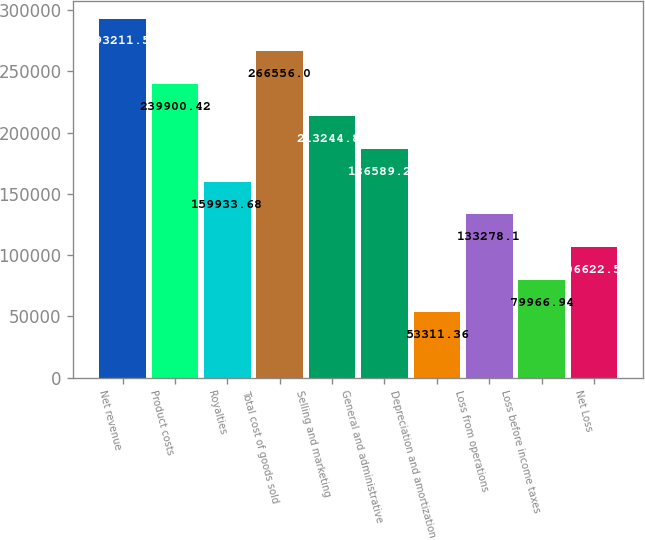Convert chart. <chart><loc_0><loc_0><loc_500><loc_500><bar_chart><fcel>Net revenue<fcel>Product costs<fcel>Royalties<fcel>Total cost of goods sold<fcel>Selling and marketing<fcel>General and administrative<fcel>Depreciation and amortization<fcel>Loss from operations<fcel>Loss before income taxes<fcel>Net Loss<nl><fcel>293212<fcel>239900<fcel>159934<fcel>266556<fcel>213245<fcel>186589<fcel>53311.4<fcel>133278<fcel>79966.9<fcel>106623<nl></chart> 